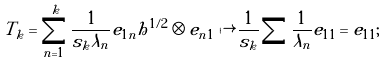<formula> <loc_0><loc_0><loc_500><loc_500>T _ { k } = \sum _ { n = 1 } ^ { k } \frac { 1 } { s _ { k } \lambda _ { n } } e _ { 1 n } h ^ { 1 / 2 } \otimes e _ { n 1 } \mapsto \frac { 1 } { s _ { k } } \sum \frac { 1 } { \lambda _ { n } } e _ { 1 1 } = e _ { 1 1 } ;</formula> 